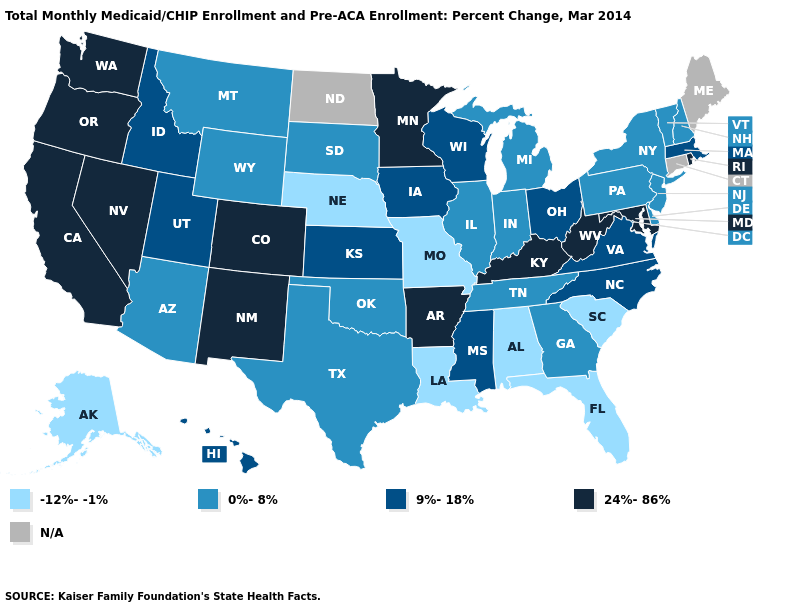Name the states that have a value in the range N/A?
Short answer required. Connecticut, Maine, North Dakota. Name the states that have a value in the range 24%-86%?
Give a very brief answer. Arkansas, California, Colorado, Kentucky, Maryland, Minnesota, Nevada, New Mexico, Oregon, Rhode Island, Washington, West Virginia. What is the lowest value in the Northeast?
Short answer required. 0%-8%. Among the states that border Arkansas , does Oklahoma have the lowest value?
Quick response, please. No. Among the states that border Washington , does Idaho have the lowest value?
Concise answer only. Yes. What is the highest value in the USA?
Keep it brief. 24%-86%. Name the states that have a value in the range 0%-8%?
Short answer required. Arizona, Delaware, Georgia, Illinois, Indiana, Michigan, Montana, New Hampshire, New Jersey, New York, Oklahoma, Pennsylvania, South Dakota, Tennessee, Texas, Vermont, Wyoming. What is the value of Montana?
Be succinct. 0%-8%. Name the states that have a value in the range 9%-18%?
Answer briefly. Hawaii, Idaho, Iowa, Kansas, Massachusetts, Mississippi, North Carolina, Ohio, Utah, Virginia, Wisconsin. Does Minnesota have the highest value in the MidWest?
Answer briefly. Yes. What is the highest value in the Northeast ?
Answer briefly. 24%-86%. What is the highest value in states that border Arizona?
Concise answer only. 24%-86%. What is the value of Georgia?
Give a very brief answer. 0%-8%. Name the states that have a value in the range 9%-18%?
Short answer required. Hawaii, Idaho, Iowa, Kansas, Massachusetts, Mississippi, North Carolina, Ohio, Utah, Virginia, Wisconsin. 